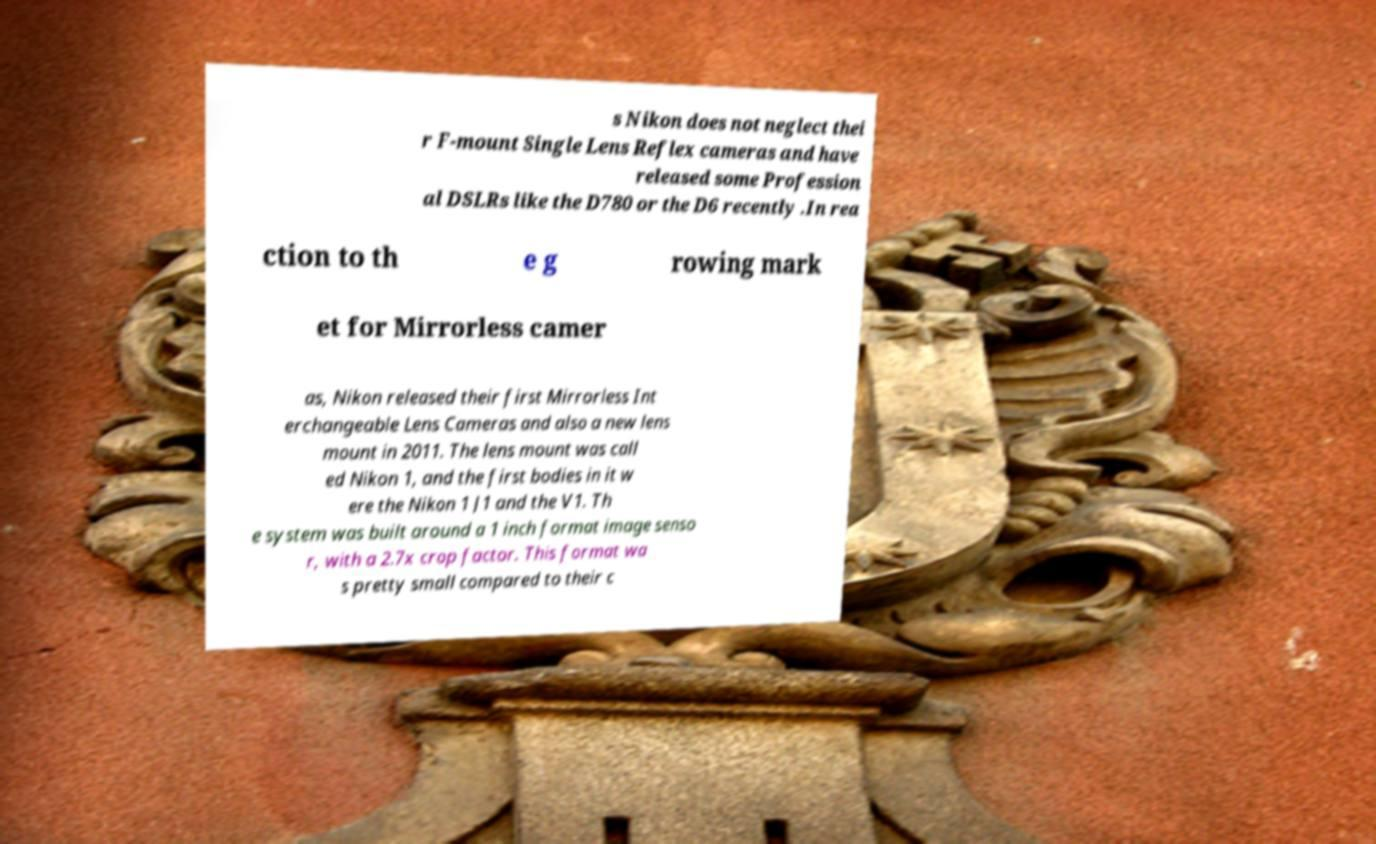There's text embedded in this image that I need extracted. Can you transcribe it verbatim? s Nikon does not neglect thei r F-mount Single Lens Reflex cameras and have released some Profession al DSLRs like the D780 or the D6 recently .In rea ction to th e g rowing mark et for Mirrorless camer as, Nikon released their first Mirrorless Int erchangeable Lens Cameras and also a new lens mount in 2011. The lens mount was call ed Nikon 1, and the first bodies in it w ere the Nikon 1 J1 and the V1. Th e system was built around a 1 inch format image senso r, with a 2.7x crop factor. This format wa s pretty small compared to their c 